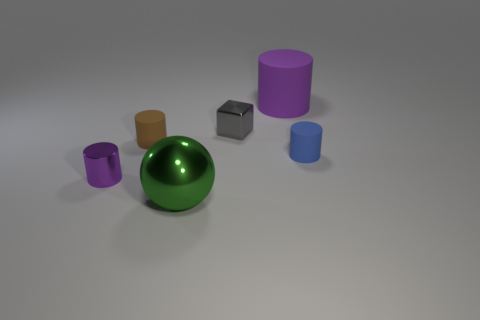Can you describe the sizes and colors of the objects in the image? Certainly! The image showcases six objects of varying sizes and colors. Starting from the left, there is a small purple cylinder, a medium-sized green sphere, a brown cube that appears to be the smallest object, a large purple cylinder, and finally two blue cylinders, one larger and one smaller. 